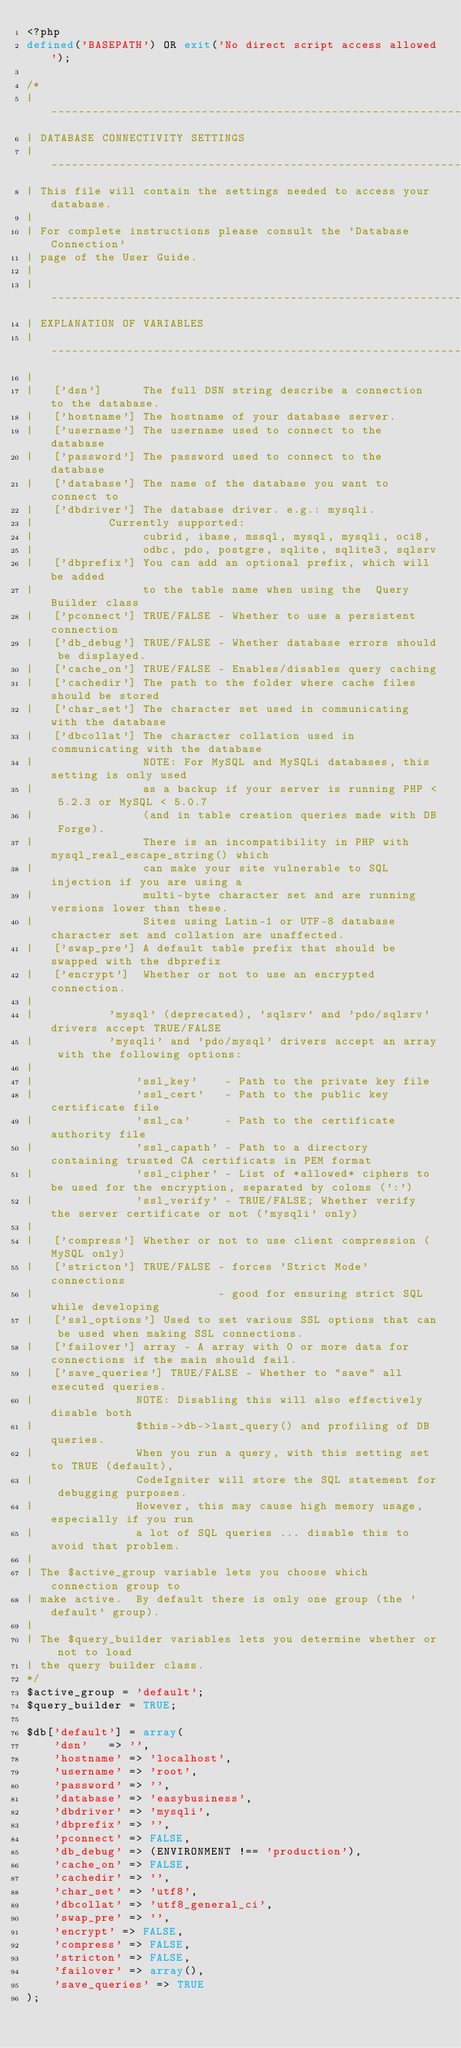Convert code to text. <code><loc_0><loc_0><loc_500><loc_500><_PHP_><?php
defined('BASEPATH') OR exit('No direct script access allowed');

/*
| -------------------------------------------------------------------
| DATABASE CONNECTIVITY SETTINGS
| -------------------------------------------------------------------
| This file will contain the settings needed to access your database.
|
| For complete instructions please consult the 'Database Connection'
| page of the User Guide.
|
| -------------------------------------------------------------------
| EXPLANATION OF VARIABLES
| -------------------------------------------------------------------
|
|	['dsn']      The full DSN string describe a connection to the database.
|	['hostname'] The hostname of your database server.
|	['username'] The username used to connect to the database
|	['password'] The password used to connect to the database
|	['database'] The name of the database you want to connect to
|	['dbdriver'] The database driver. e.g.: mysqli.
|			Currently supported:
|				 cubrid, ibase, mssql, mysql, mysqli, oci8,
|				 odbc, pdo, postgre, sqlite, sqlite3, sqlsrv
|	['dbprefix'] You can add an optional prefix, which will be added
|				 to the table name when using the  Query Builder class
|	['pconnect'] TRUE/FALSE - Whether to use a persistent connection
|	['db_debug'] TRUE/FALSE - Whether database errors should be displayed.
|	['cache_on'] TRUE/FALSE - Enables/disables query caching
|	['cachedir'] The path to the folder where cache files should be stored
|	['char_set'] The character set used in communicating with the database
|	['dbcollat'] The character collation used in communicating with the database
|				 NOTE: For MySQL and MySQLi databases, this setting is only used
| 				 as a backup if your server is running PHP < 5.2.3 or MySQL < 5.0.7
|				 (and in table creation queries made with DB Forge).
| 				 There is an incompatibility in PHP with mysql_real_escape_string() which
| 				 can make your site vulnerable to SQL injection if you are using a
| 				 multi-byte character set and are running versions lower than these.
| 				 Sites using Latin-1 or UTF-8 database character set and collation are unaffected.
|	['swap_pre'] A default table prefix that should be swapped with the dbprefix
|	['encrypt']  Whether or not to use an encrypted connection.
|
|			'mysql' (deprecated), 'sqlsrv' and 'pdo/sqlsrv' drivers accept TRUE/FALSE
|			'mysqli' and 'pdo/mysql' drivers accept an array with the following options:
|
|				'ssl_key'    - Path to the private key file
|				'ssl_cert'   - Path to the public key certificate file
|				'ssl_ca'     - Path to the certificate authority file
|				'ssl_capath' - Path to a directory containing trusted CA certificats in PEM format
|				'ssl_cipher' - List of *allowed* ciphers to be used for the encryption, separated by colons (':')
|				'ssl_verify' - TRUE/FALSE; Whether verify the server certificate or not ('mysqli' only)
|
|	['compress'] Whether or not to use client compression (MySQL only)
|	['stricton'] TRUE/FALSE - forces 'Strict Mode' connections
|							- good for ensuring strict SQL while developing
|	['ssl_options']	Used to set various SSL options that can be used when making SSL connections.
|	['failover'] array - A array with 0 or more data for connections if the main should fail.
|	['save_queries'] TRUE/FALSE - Whether to "save" all executed queries.
| 				NOTE: Disabling this will also effectively disable both
| 				$this->db->last_query() and profiling of DB queries.
| 				When you run a query, with this setting set to TRUE (default),
| 				CodeIgniter will store the SQL statement for debugging purposes.
| 				However, this may cause high memory usage, especially if you run
| 				a lot of SQL queries ... disable this to avoid that problem.
|
| The $active_group variable lets you choose which connection group to
| make active.  By default there is only one group (the 'default' group).
|
| The $query_builder variables lets you determine whether or not to load
| the query builder class.
*/
$active_group = 'default';
$query_builder = TRUE;

$db['default'] = array(
	'dsn'	=> '',
	'hostname' => 'localhost',
	'username' => 'root',
	'password' => '',
	'database' => 'easybusiness',
	'dbdriver' => 'mysqli',
	'dbprefix' => '',
	'pconnect' => FALSE,
	'db_debug' => (ENVIRONMENT !== 'production'),
	'cache_on' => FALSE,
	'cachedir' => '',
	'char_set' => 'utf8',
	'dbcollat' => 'utf8_general_ci',
	'swap_pre' => '',
	'encrypt' => FALSE,
	'compress' => FALSE,
	'stricton' => FALSE,
	'failover' => array(),
	'save_queries' => TRUE
);
</code> 